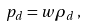<formula> <loc_0><loc_0><loc_500><loc_500>p _ { d } = w \rho _ { d } \, ,</formula> 